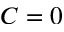<formula> <loc_0><loc_0><loc_500><loc_500>C = 0</formula> 